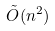Convert formula to latex. <formula><loc_0><loc_0><loc_500><loc_500>\tilde { O } ( n ^ { 2 } )</formula> 